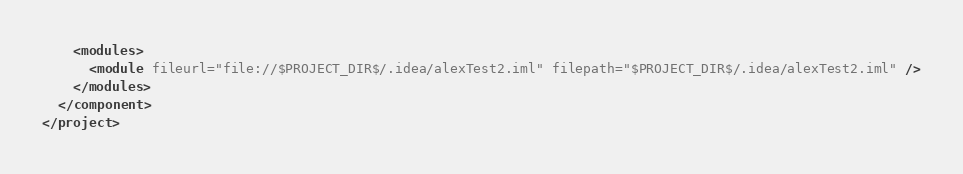Convert code to text. <code><loc_0><loc_0><loc_500><loc_500><_XML_>    <modules>
      <module fileurl="file://$PROJECT_DIR$/.idea/alexTest2.iml" filepath="$PROJECT_DIR$/.idea/alexTest2.iml" />
    </modules>
  </component>
</project></code> 